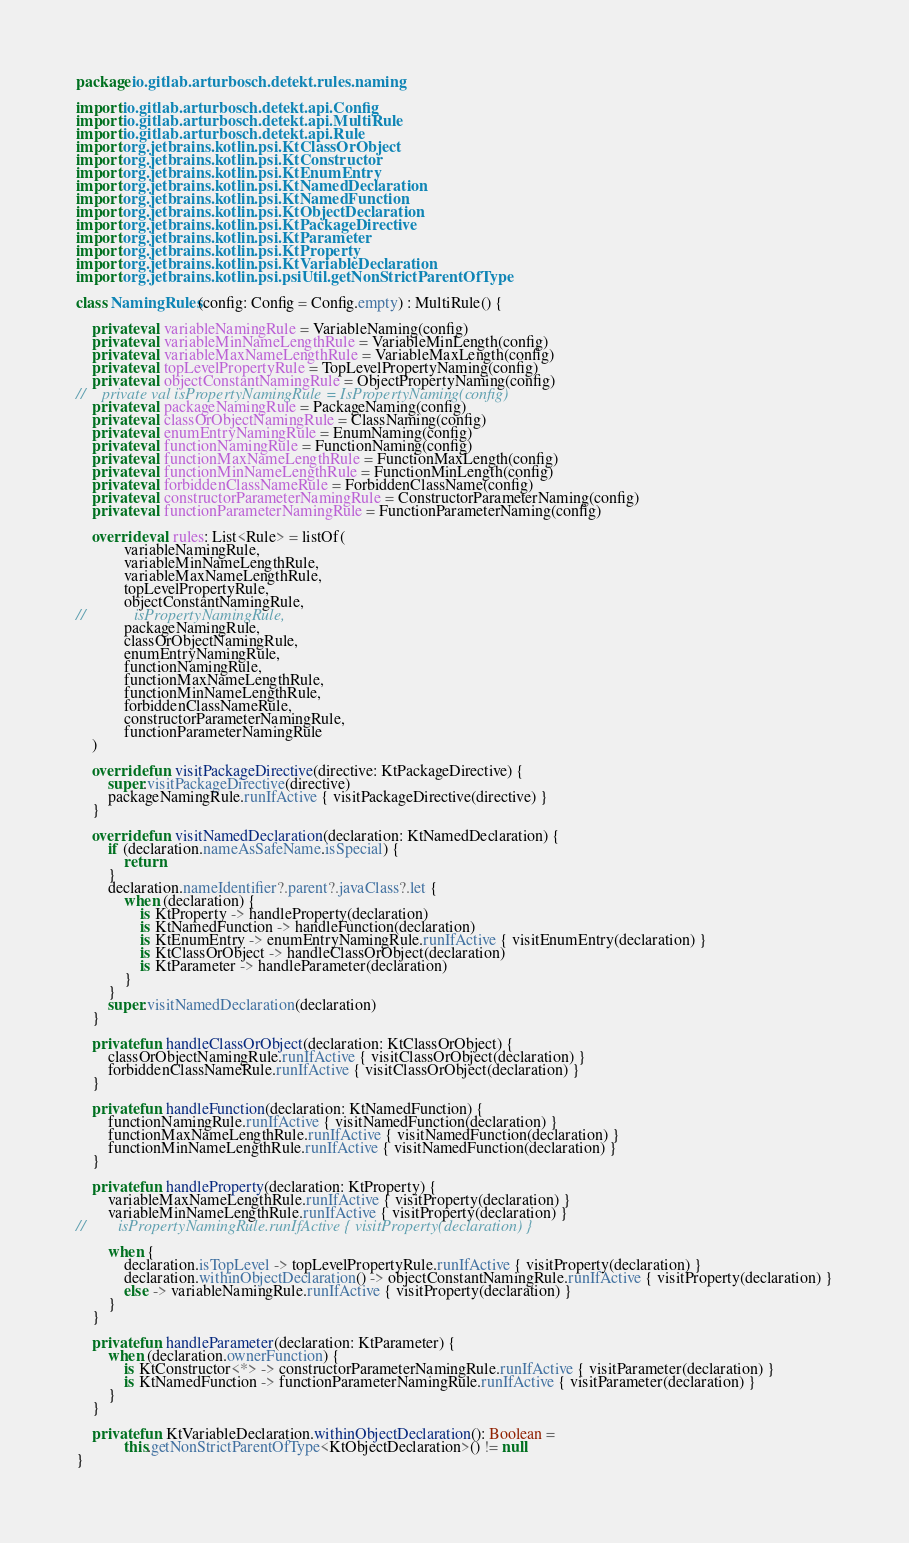<code> <loc_0><loc_0><loc_500><loc_500><_Kotlin_>package io.gitlab.arturbosch.detekt.rules.naming

import io.gitlab.arturbosch.detekt.api.Config
import io.gitlab.arturbosch.detekt.api.MultiRule
import io.gitlab.arturbosch.detekt.api.Rule
import org.jetbrains.kotlin.psi.KtClassOrObject
import org.jetbrains.kotlin.psi.KtConstructor
import org.jetbrains.kotlin.psi.KtEnumEntry
import org.jetbrains.kotlin.psi.KtNamedDeclaration
import org.jetbrains.kotlin.psi.KtNamedFunction
import org.jetbrains.kotlin.psi.KtObjectDeclaration
import org.jetbrains.kotlin.psi.KtPackageDirective
import org.jetbrains.kotlin.psi.KtParameter
import org.jetbrains.kotlin.psi.KtProperty
import org.jetbrains.kotlin.psi.KtVariableDeclaration
import org.jetbrains.kotlin.psi.psiUtil.getNonStrictParentOfType

class NamingRules(config: Config = Config.empty) : MultiRule() {

    private val variableNamingRule = VariableNaming(config)
    private val variableMinNameLengthRule = VariableMinLength(config)
    private val variableMaxNameLengthRule = VariableMaxLength(config)
    private val topLevelPropertyRule = TopLevelPropertyNaming(config)
    private val objectConstantNamingRule = ObjectPropertyNaming(config)
//    private val isPropertyNamingRule = IsPropertyNaming(config)
    private val packageNamingRule = PackageNaming(config)
    private val classOrObjectNamingRule = ClassNaming(config)
    private val enumEntryNamingRule = EnumNaming(config)
    private val functionNamingRule = FunctionNaming(config)
    private val functionMaxNameLengthRule = FunctionMaxLength(config)
    private val functionMinNameLengthRule = FunctionMinLength(config)
    private val forbiddenClassNameRule = ForbiddenClassName(config)
    private val constructorParameterNamingRule = ConstructorParameterNaming(config)
    private val functionParameterNamingRule = FunctionParameterNaming(config)

    override val rules: List<Rule> = listOf(
            variableNamingRule,
            variableMinNameLengthRule,
            variableMaxNameLengthRule,
            topLevelPropertyRule,
            objectConstantNamingRule,
//            isPropertyNamingRule,
            packageNamingRule,
            classOrObjectNamingRule,
            enumEntryNamingRule,
            functionNamingRule,
            functionMaxNameLengthRule,
            functionMinNameLengthRule,
            forbiddenClassNameRule,
            constructorParameterNamingRule,
            functionParameterNamingRule
    )

    override fun visitPackageDirective(directive: KtPackageDirective) {
        super.visitPackageDirective(directive)
        packageNamingRule.runIfActive { visitPackageDirective(directive) }
    }

    override fun visitNamedDeclaration(declaration: KtNamedDeclaration) {
        if (declaration.nameAsSafeName.isSpecial) {
            return
        }
        declaration.nameIdentifier?.parent?.javaClass?.let {
            when (declaration) {
                is KtProperty -> handleProperty(declaration)
                is KtNamedFunction -> handleFunction(declaration)
                is KtEnumEntry -> enumEntryNamingRule.runIfActive { visitEnumEntry(declaration) }
                is KtClassOrObject -> handleClassOrObject(declaration)
                is KtParameter -> handleParameter(declaration)
            }
        }
        super.visitNamedDeclaration(declaration)
    }

    private fun handleClassOrObject(declaration: KtClassOrObject) {
        classOrObjectNamingRule.runIfActive { visitClassOrObject(declaration) }
        forbiddenClassNameRule.runIfActive { visitClassOrObject(declaration) }
    }

    private fun handleFunction(declaration: KtNamedFunction) {
        functionNamingRule.runIfActive { visitNamedFunction(declaration) }
        functionMaxNameLengthRule.runIfActive { visitNamedFunction(declaration) }
        functionMinNameLengthRule.runIfActive { visitNamedFunction(declaration) }
    }

    private fun handleProperty(declaration: KtProperty) {
        variableMaxNameLengthRule.runIfActive { visitProperty(declaration) }
        variableMinNameLengthRule.runIfActive { visitProperty(declaration) }
//        isPropertyNamingRule.runIfActive { visitProperty(declaration) }

        when {
            declaration.isTopLevel -> topLevelPropertyRule.runIfActive { visitProperty(declaration) }
            declaration.withinObjectDeclaration() -> objectConstantNamingRule.runIfActive { visitProperty(declaration) }
            else -> variableNamingRule.runIfActive { visitProperty(declaration) }
        }
    }

    private fun handleParameter(declaration: KtParameter) {
        when (declaration.ownerFunction) {
            is KtConstructor<*> -> constructorParameterNamingRule.runIfActive { visitParameter(declaration) }
            is KtNamedFunction -> functionParameterNamingRule.runIfActive { visitParameter(declaration) }
        }
    }

    private fun KtVariableDeclaration.withinObjectDeclaration(): Boolean =
            this.getNonStrictParentOfType<KtObjectDeclaration>() != null
}
</code> 